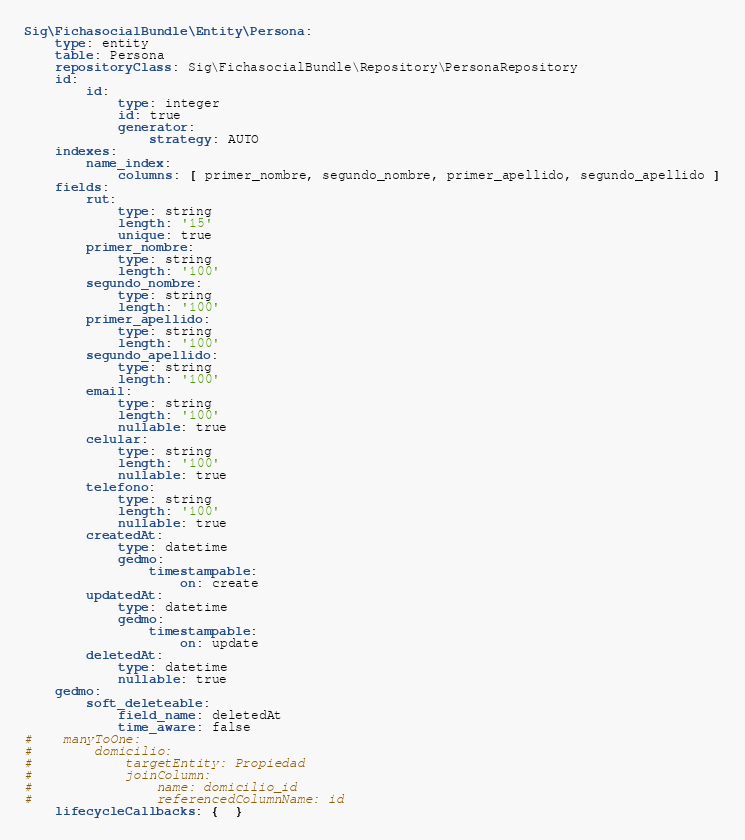Convert code to text. <code><loc_0><loc_0><loc_500><loc_500><_YAML_>Sig\FichasocialBundle\Entity\Persona:
    type: entity
    table: Persona
    repositoryClass: Sig\FichasocialBundle\Repository\PersonaRepository
    id:
        id:
            type: integer
            id: true
            generator:
                strategy: AUTO
    indexes:
        name_index:
            columns: [ primer_nombre, segundo_nombre, primer_apellido, segundo_apellido ]
    fields:
        rut:
            type: string
            length: '15'
            unique: true
        primer_nombre:
            type: string
            length: '100'
        segundo_nombre:
            type: string
            length: '100'
        primer_apellido:
            type: string
            length: '100'
        segundo_apellido:
            type: string
            length: '100'
        email:
            type: string
            length: '100'
            nullable: true
        celular:
            type: string
            length: '100'
            nullable: true
        telefono:
            type: string
            length: '100'
            nullable: true
        createdAt:
            type: datetime
            gedmo:
                timestampable:
                    on: create
        updatedAt:
            type: datetime
            gedmo:
                timestampable:
                    on: update
        deletedAt:
            type: datetime
            nullable: true
    gedmo:
        soft_deleteable:
            field_name: deletedAt
            time_aware: false
#    manyToOne:
#        domicilio:
#            targetEntity: Propiedad
#            joinColumn:
#                name: domicilio_id
#                referencedColumnName: id
    lifecycleCallbacks: {  }
</code> 